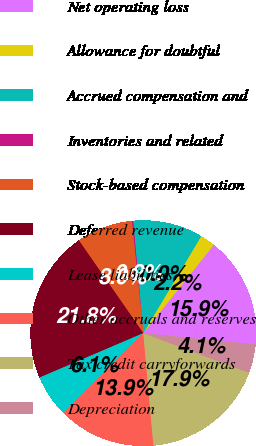Convert chart. <chart><loc_0><loc_0><loc_500><loc_500><pie_chart><fcel>Net operating loss<fcel>Allowance for doubtful<fcel>Accrued compensation and<fcel>Inventories and related<fcel>Stock-based compensation<fcel>Deferred revenue<fcel>Lease liabilities<fcel>Other accruals and reserves<fcel>Tax credit carryforwards<fcel>Depreciation<nl><fcel>15.88%<fcel>2.15%<fcel>10.0%<fcel>0.19%<fcel>8.04%<fcel>21.77%<fcel>6.08%<fcel>13.92%<fcel>17.85%<fcel>4.12%<nl></chart> 